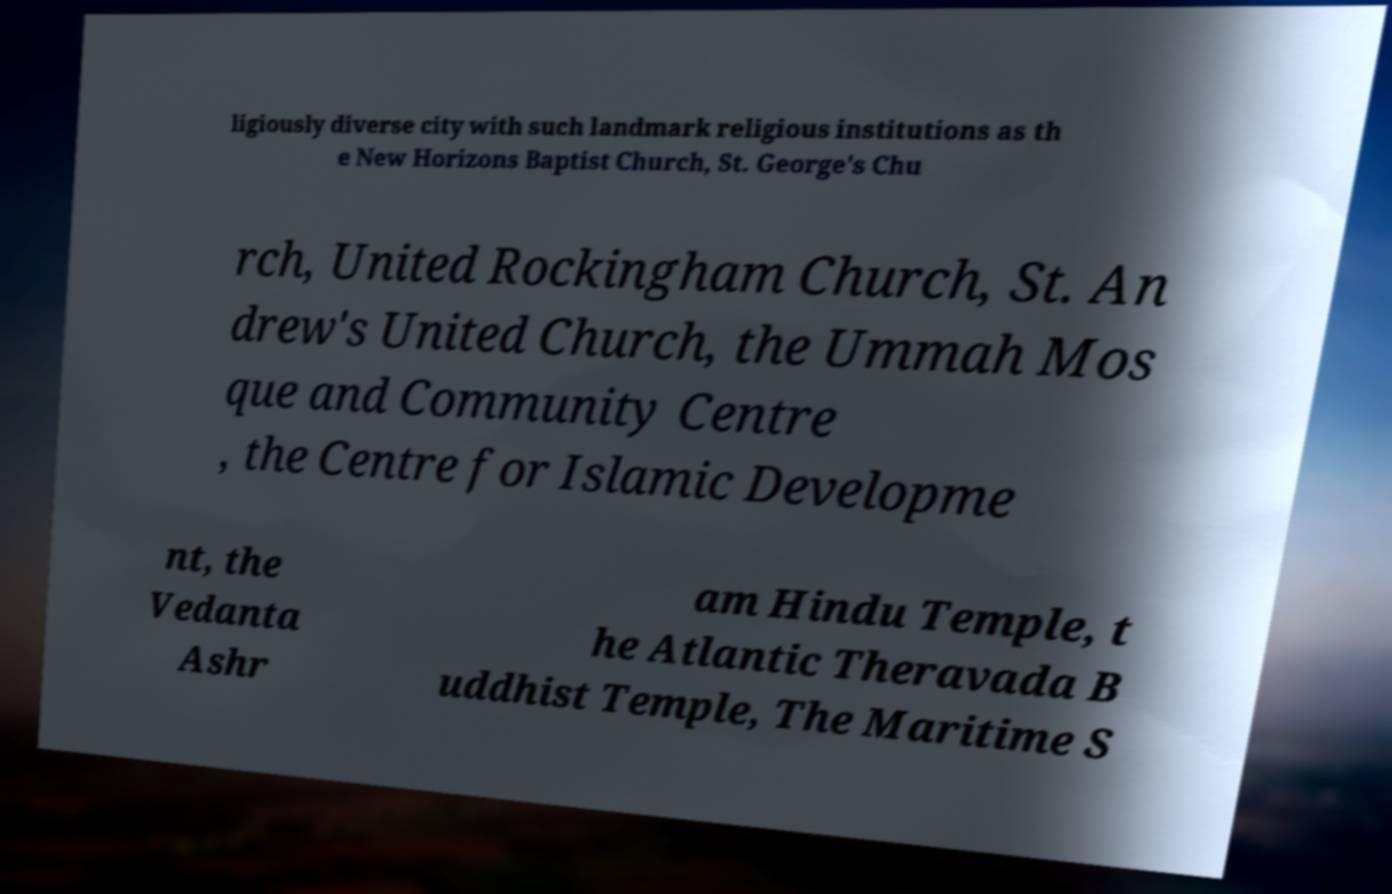There's text embedded in this image that I need extracted. Can you transcribe it verbatim? ligiously diverse city with such landmark religious institutions as th e New Horizons Baptist Church, St. George's Chu rch, United Rockingham Church, St. An drew's United Church, the Ummah Mos que and Community Centre , the Centre for Islamic Developme nt, the Vedanta Ashr am Hindu Temple, t he Atlantic Theravada B uddhist Temple, The Maritime S 